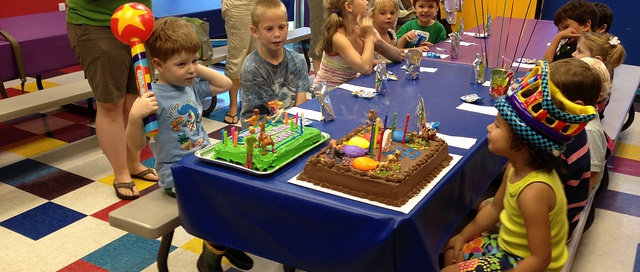Describe the objects in this image and their specific colors. I can see dining table in maroon, gray, brown, and white tones, people in maroon, black, and olive tones, people in maroon, gray, black, and brown tones, cake in maroon, brown, and gray tones, and people in maroon, black, gray, and olive tones in this image. 